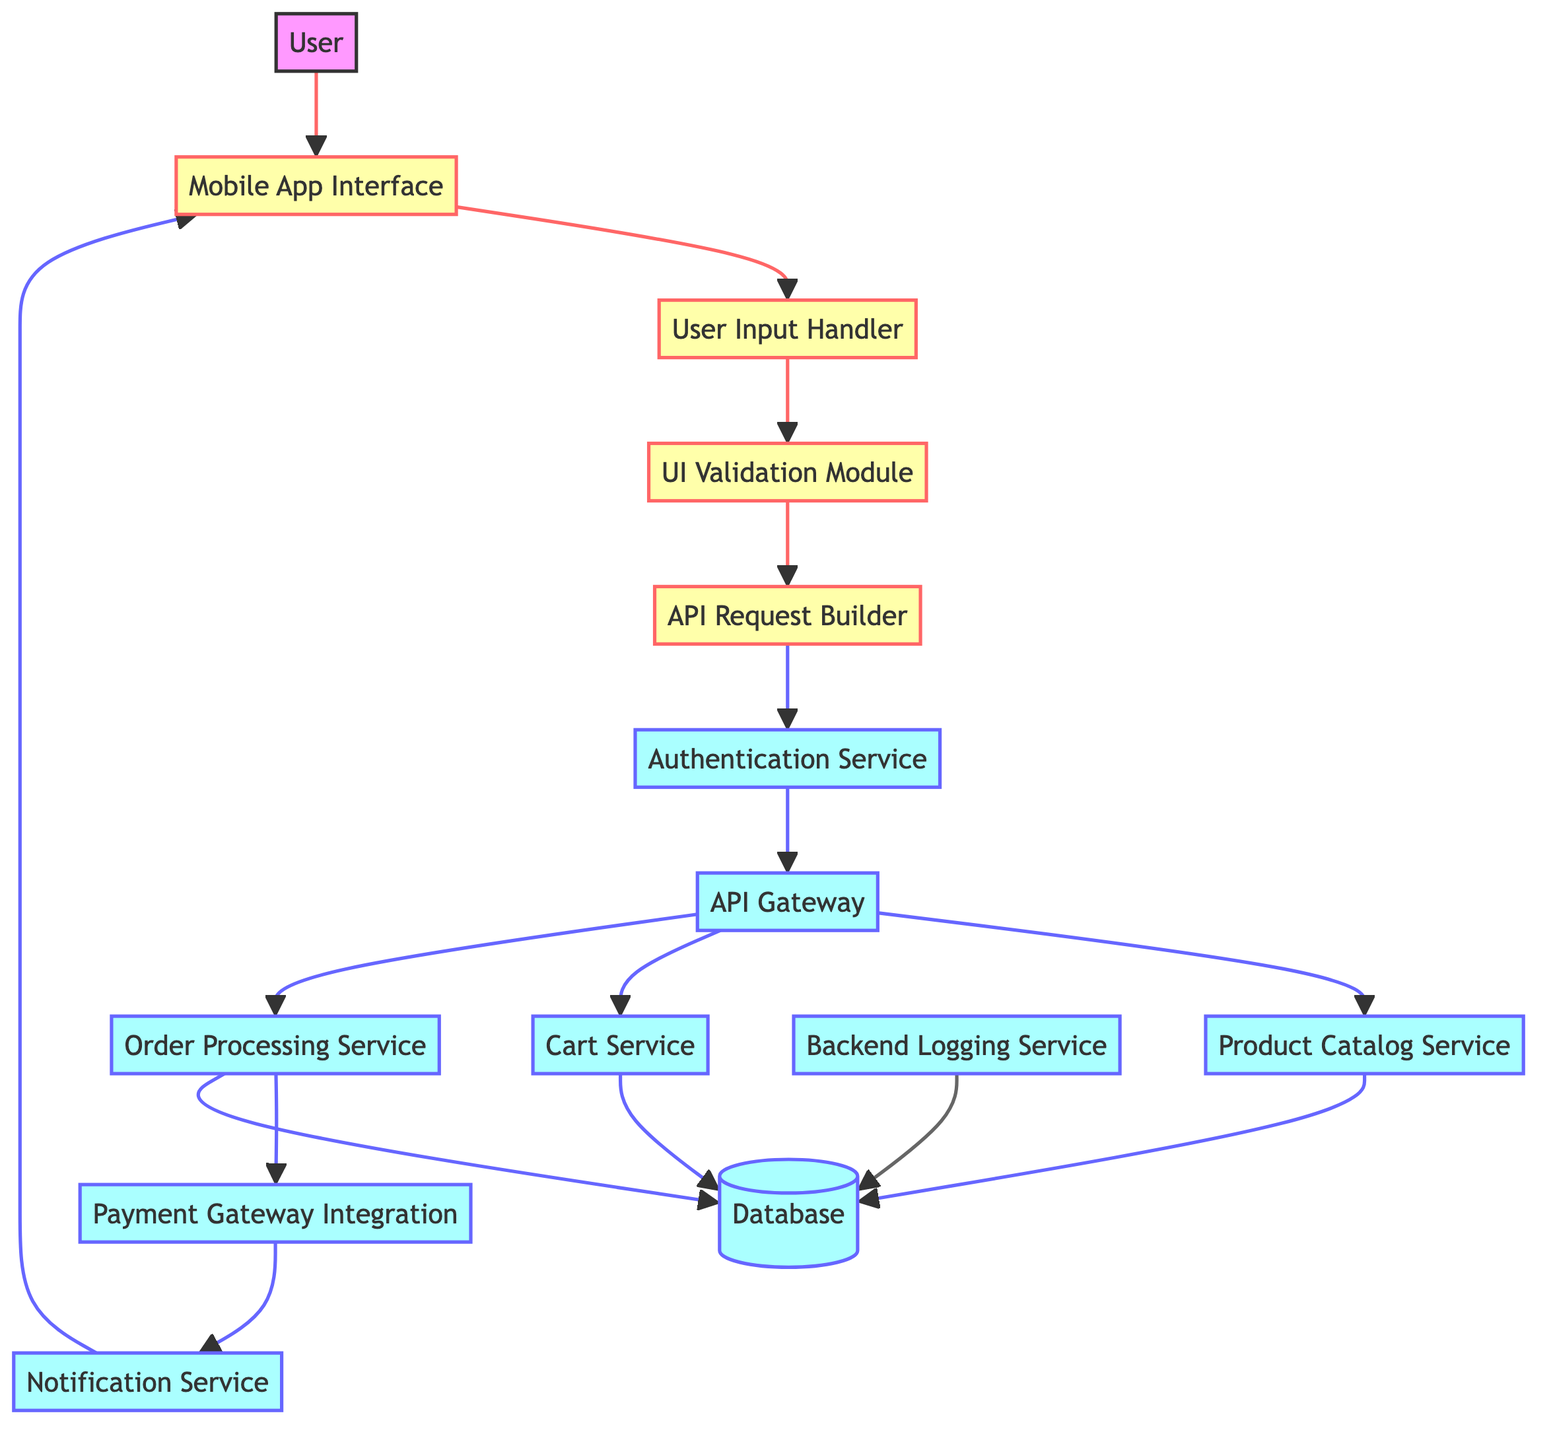What is the starting point of the data flow? The starting point of the data flow is represented by the node "User," which initiates interactions with the mobile app.
Answer: User How many services interface directly with the API Gateway? The API Gateway interacts with three services: Product Catalog Service, Cart Service, and Order Processing Service, which can be traced directly from the connections on the diagram.
Answer: 3 Which module follows the User Input Handler in the data flow? After the User Input Handler, the next module in the flow is the UI Validation Module, which processes incoming user inputs.
Answer: UI Validation Module What service is responsible for managing the user's shopping cart? The service that manages the user's shopping cart is the Cart Service, as indicated by its role in the diagram.
Answer: Cart Service What action does the Notification Service perform after processing a payment? After the Payment Gateway Integration processes a payment, the action performed by the Notification Service is to send confirmation messages and updates to the user.
Answer: Send confirmation messages Which two components are involved in authenticating a user? The components involved in authenticating a user are the Authentication Service and the API Gateway, where the flow goes from Authentication Service to API Gateway.
Answer: Authentication Service, API Gateway Identify the service that stores product details. The service responsible for storing product details is the Database, which holds all relevant data including user and product information as per diagram.
Answer: Database How does data flow from the Order Processing Service? The flow from the Order Processing Service goes to the Payment Gateway Integration next and subsequently to the Notification Service, indicating a sequential processing of data linked to order placements.
Answer: To Payment Gateway Integration and Notification Service What acts as the central routing point for API requests? The central routing point for API requests is the API Gateway, which routes requests to the corresponding back-end services as depicted in the diagram.
Answer: API Gateway 